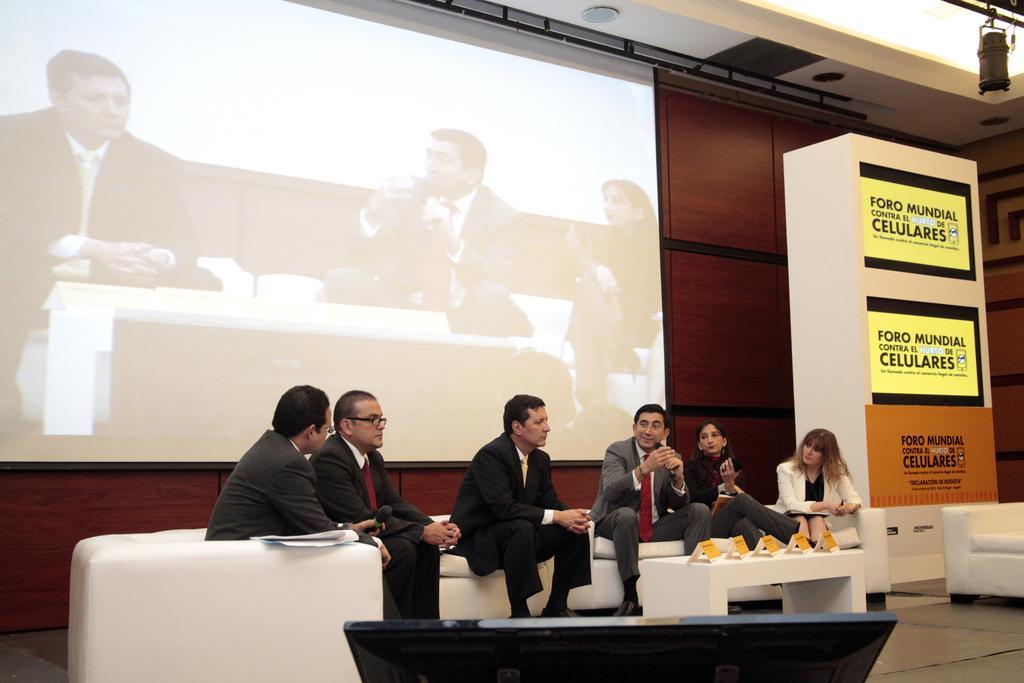Can you describe this image briefly? There is a projector displaying few persons. And behind that there is a sofa there are people sitting on sofa and in which two are woman and four are man. who are speaking to each other. Behind them there is a box displayed by their logos. and above that there is a light focusing on them. 